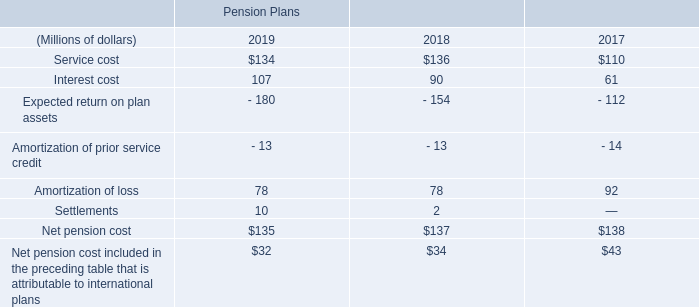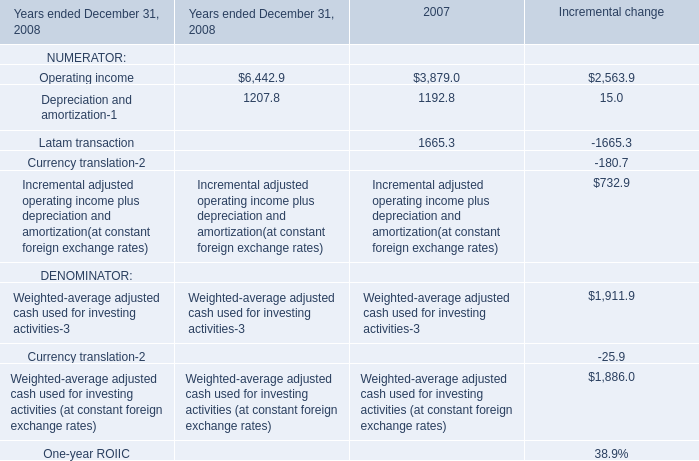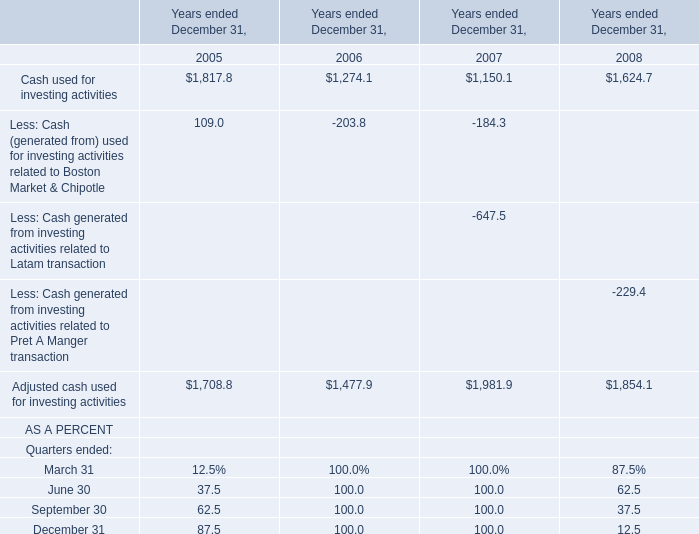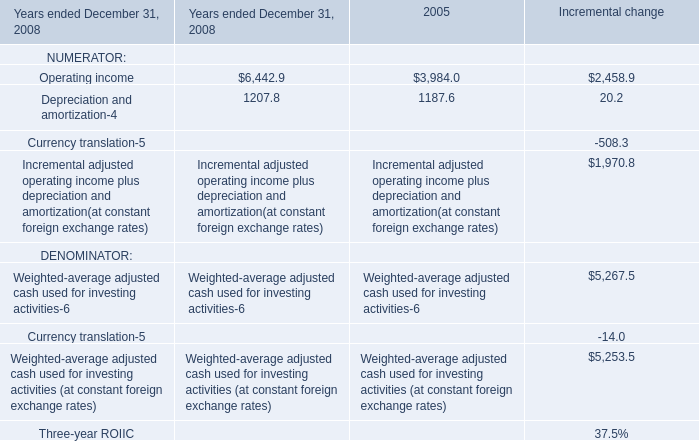What is the average amount of Operating income of Incremental change, and Depreciation and amortization of 2007 ? 
Computations: ((2458.9 + 1192.8) / 2)
Answer: 1825.85. 